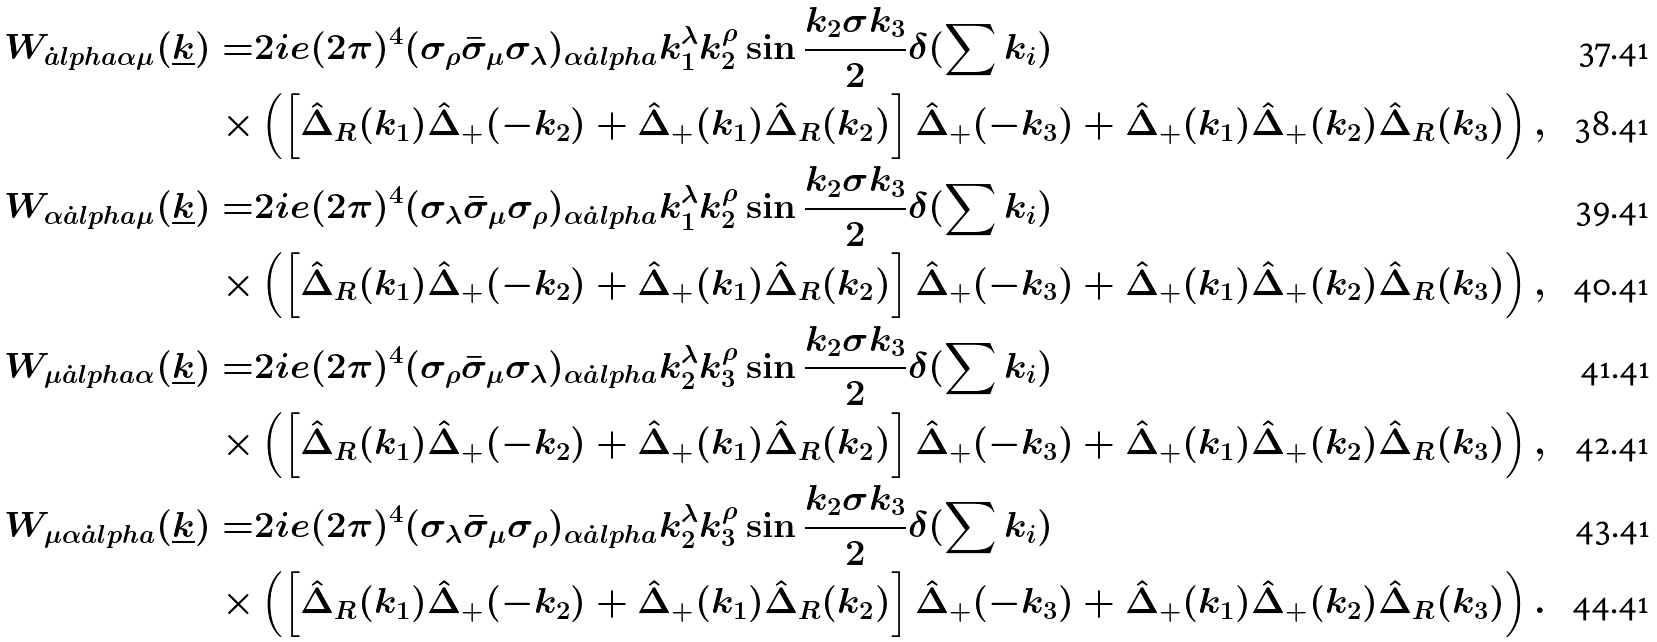<formula> <loc_0><loc_0><loc_500><loc_500>W _ { \dot { a } l p h a \alpha \mu } ( \underline { k } ) = & 2 i e ( 2 \pi ) ^ { 4 } ( \sigma _ { \rho } \bar { \sigma } _ { \mu } \sigma _ { \lambda } ) _ { \alpha \dot { a } l p h a } k _ { 1 } ^ { \lambda } k _ { 2 } ^ { \rho } \sin \frac { k _ { 2 } \sigma k _ { 3 } } { 2 } \delta ( \sum k _ { i } ) \\ \times & \left ( \left [ \hat { \Delta } _ { R } ( k _ { 1 } ) \hat { \Delta } _ { + } ( - k _ { 2 } ) + \hat { \Delta } _ { + } ( k _ { 1 } ) \hat { \Delta } _ { R } ( k _ { 2 } ) \right ] \hat { \Delta } _ { + } ( - k _ { 3 } ) + \hat { \Delta } _ { + } ( k _ { 1 } ) \hat { \Delta } _ { + } ( k _ { 2 } ) \hat { \Delta } _ { R } ( k _ { 3 } ) \right ) , \\ W _ { \alpha \dot { a } l p h a \mu } ( \underline { k } ) = & 2 i e ( 2 \pi ) ^ { 4 } ( \sigma _ { \lambda } \bar { \sigma } _ { \mu } \sigma _ { \rho } ) _ { \alpha \dot { a } l p h a } k _ { 1 } ^ { \lambda } k _ { 2 } ^ { \rho } \sin \frac { k _ { 2 } \sigma k _ { 3 } } { 2 } \delta ( \sum k _ { i } ) \\ \times & \left ( \left [ \hat { \Delta } _ { R } ( k _ { 1 } ) \hat { \Delta } _ { + } ( - k _ { 2 } ) + \hat { \Delta } _ { + } ( k _ { 1 } ) \hat { \Delta } _ { R } ( k _ { 2 } ) \right ] \hat { \Delta } _ { + } ( - k _ { 3 } ) + \hat { \Delta } _ { + } ( k _ { 1 } ) \hat { \Delta } _ { + } ( k _ { 2 } ) \hat { \Delta } _ { R } ( k _ { 3 } ) \right ) , \\ W _ { \mu \dot { a } l p h a \alpha } ( \underline { k } ) = & 2 i e ( 2 \pi ) ^ { 4 } ( \sigma _ { \rho } \bar { \sigma } _ { \mu } \sigma _ { \lambda } ) _ { \alpha \dot { a } l p h a } k _ { 2 } ^ { \lambda } k _ { 3 } ^ { \rho } \sin \frac { k _ { 2 } \sigma k _ { 3 } } { 2 } \delta ( \sum k _ { i } ) \\ \times & \left ( \left [ \hat { \Delta } _ { R } ( k _ { 1 } ) \hat { \Delta } _ { + } ( - k _ { 2 } ) + \hat { \Delta } _ { + } ( k _ { 1 } ) \hat { \Delta } _ { R } ( k _ { 2 } ) \right ] \hat { \Delta } _ { + } ( - k _ { 3 } ) + \hat { \Delta } _ { + } ( k _ { 1 } ) \hat { \Delta } _ { + } ( k _ { 2 } ) \hat { \Delta } _ { R } ( k _ { 3 } ) \right ) , \\ W _ { \mu \alpha \dot { a } l p h a } ( \underline { k } ) = & 2 i e ( 2 \pi ) ^ { 4 } ( \sigma _ { \lambda } \bar { \sigma } _ { \mu } \sigma _ { \rho } ) _ { \alpha \dot { a } l p h a } k _ { 2 } ^ { \lambda } k _ { 3 } ^ { \rho } \sin \frac { k _ { 2 } \sigma k _ { 3 } } { 2 } \delta ( \sum k _ { i } ) \\ \times & \left ( \left [ \hat { \Delta } _ { R } ( k _ { 1 } ) \hat { \Delta } _ { + } ( - k _ { 2 } ) + \hat { \Delta } _ { + } ( k _ { 1 } ) \hat { \Delta } _ { R } ( k _ { 2 } ) \right ] \hat { \Delta } _ { + } ( - k _ { 3 } ) + \hat { \Delta } _ { + } ( k _ { 1 } ) \hat { \Delta } _ { + } ( k _ { 2 } ) \hat { \Delta } _ { R } ( k _ { 3 } ) \right ) .</formula> 